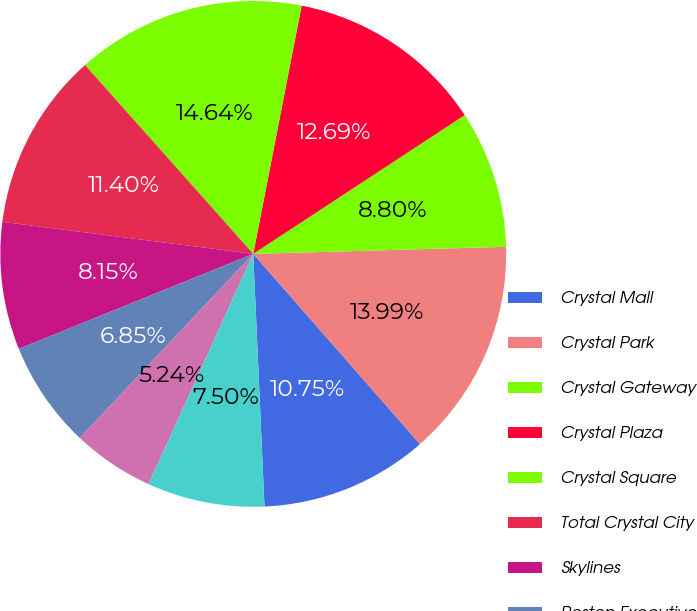Convert chart to OTSL. <chart><loc_0><loc_0><loc_500><loc_500><pie_chart><fcel>Crystal Mall<fcel>Crystal Park<fcel>Crystal Gateway<fcel>Crystal Plaza<fcel>Crystal Square<fcel>Total Crystal City<fcel>Skylines<fcel>Reston Executive<fcel>Commerce Executive<fcel>Tysons Dulles<nl><fcel>10.75%<fcel>14.0%<fcel>8.8%<fcel>12.7%<fcel>14.65%<fcel>11.4%<fcel>8.15%<fcel>6.85%<fcel>5.24%<fcel>7.5%<nl></chart> 